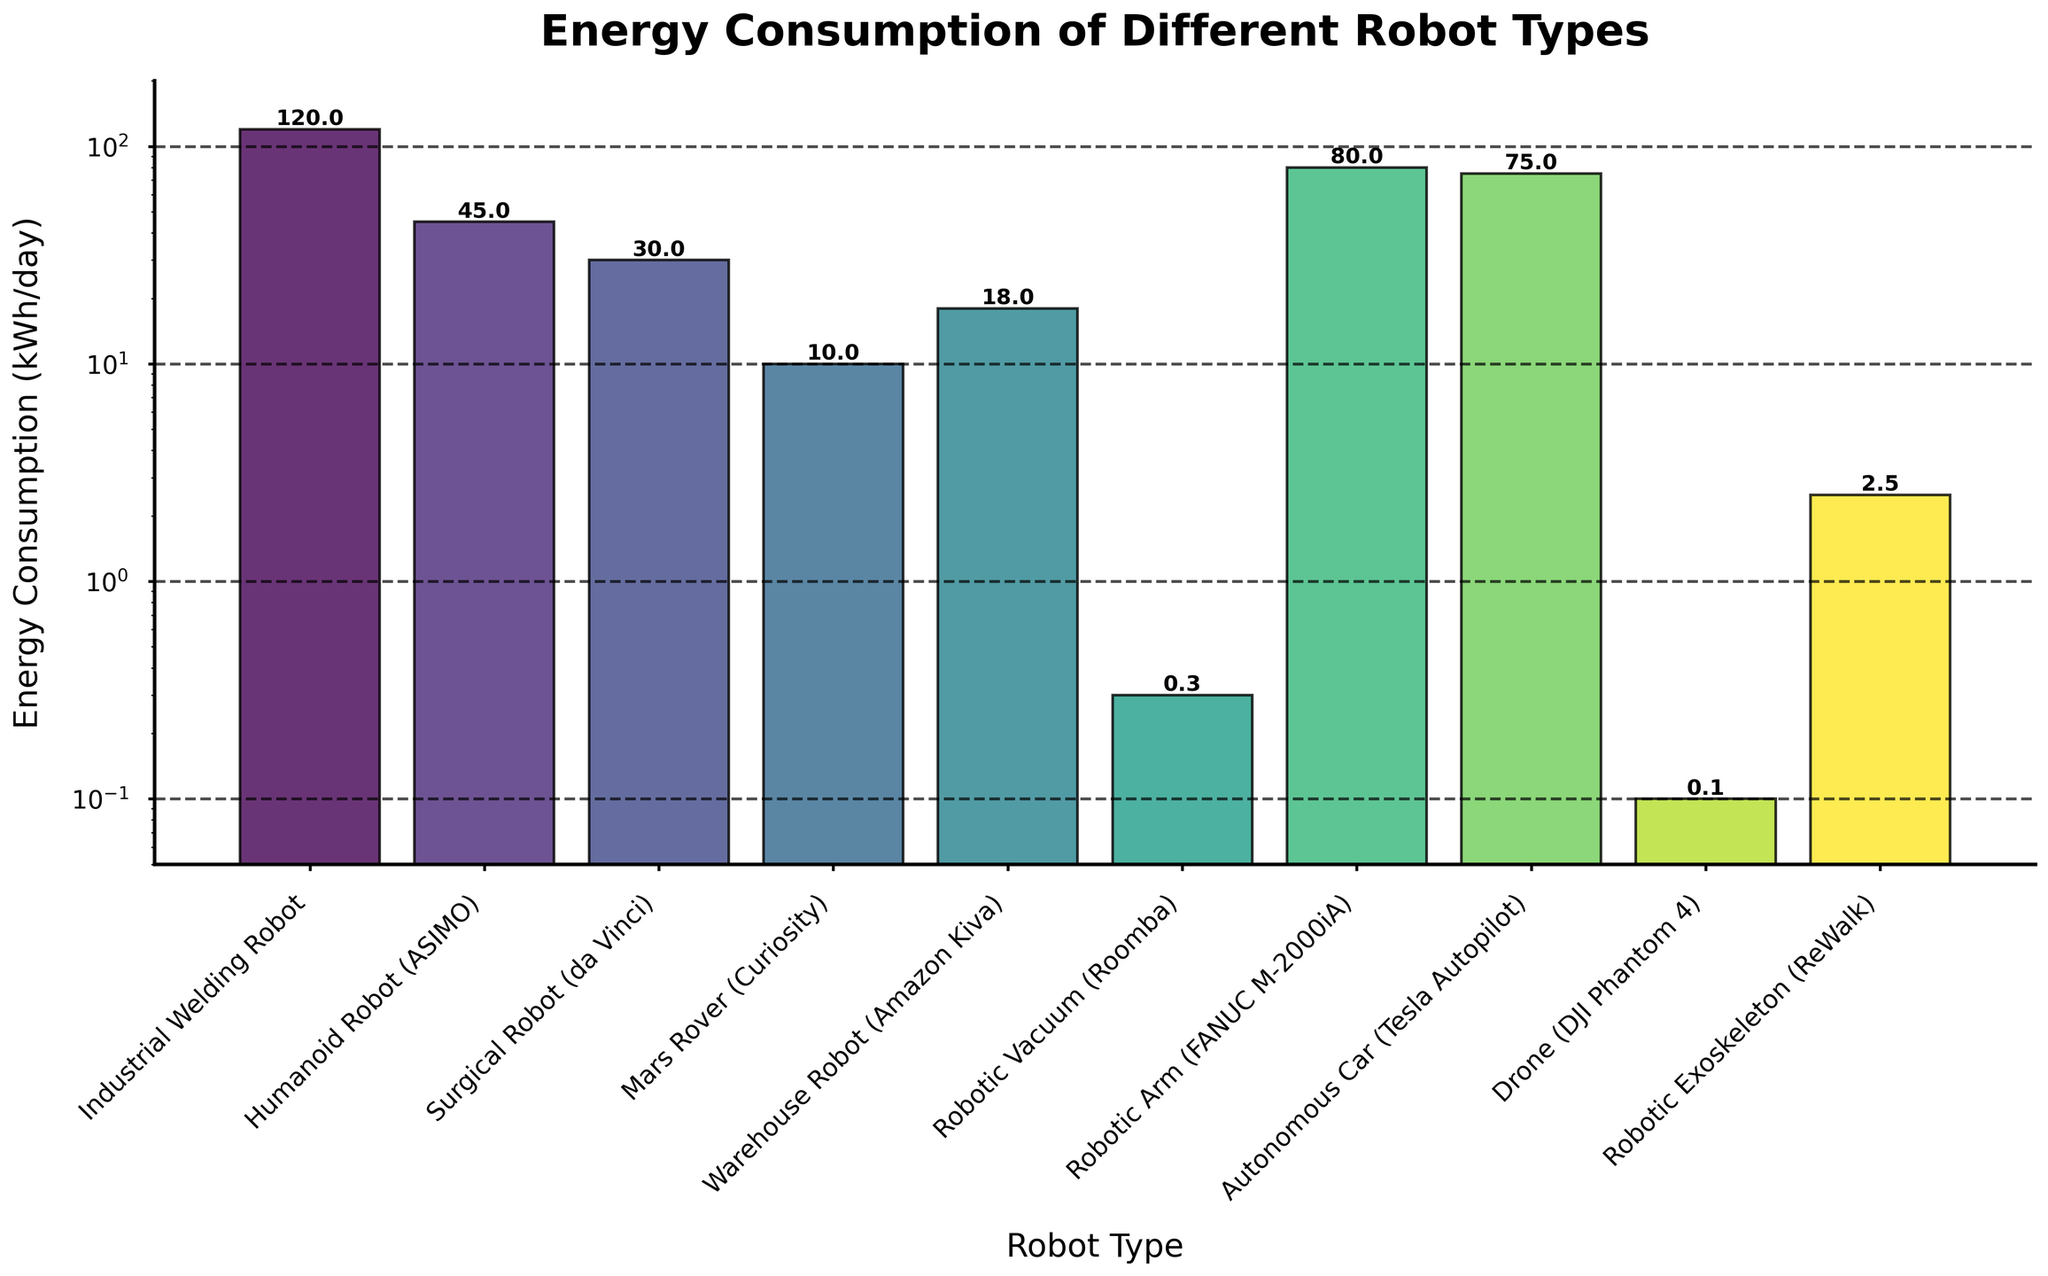What's the highest energy consumption of the robots shown on the chart? The bar with the highest height represents the Industrial Welding Robot with an energy consumption value of 120 kWh/day.
Answer: 120 kWh/day Which robot type consumes the least energy? The shortest bar on the chart represents the Drone (DJI Phantom 4), with an energy consumption of 0.1 kWh/day.
Answer: Drone (DJI Phantom 4) What's the combined energy consumption of the Industrial Welding Robot and the Robotic Arm? The energy consumption for the Industrial Welding Robot is 120 kWh/day, and for the Robotic Arm, it is 80 kWh/day. Adding these two values: 120 + 80 = 200 kWh/day.
Answer: 200 kWh/day Is the energy consumption of the Autonomous Car higher than that of the Humanoid Robot? The bar representing the Autonomous Car (Tesla Autopilot) has a height corresponding to 75 kWh/day, while the Humanoid Robot (ASIMO) has a height corresponding to 45 kWh/day. Since 75 is greater than 45, the energy consumption of the Autonomous Car is higher.
Answer: Yes What is the difference in energy consumption between the Surgical Robot and the Warehouse Robot? The energy consumption of the Surgical Robot (da Vinci) is 30 kWh/day, and that of the Warehouse Robot (Amazon Kiva) is 18 kWh/day. The difference is 30 - 18 = 12 kWh/day.
Answer: 12 kWh/day Is the energy consumption of the Mars Rover lower than that of the Robotic Exoskeleton? Comparing the heights of the bars, the Mars Rover (Curiosity) consumes 10 kWh/day while the Robotic Exoskeleton (ReWalk) consumes 2.5 kWh/day. Since 2.5 is less than 10, the Mars Rover's consumption is higher.
Answer: No Which three robots have the lowest energy consumption? By glancing at the shortest bars in ascending order: Drone (DJI Phantom 4) with 0.1 kWh/day, Robotic Vacuum (Roomba) with 0.3 kWh/day, and Robotic Exoskeleton (ReWalk) with 2.5 kWh/day.
Answer: Drone, Roomba, ReWalk What portion of the total energy consumption is taken up by the Autonomous Car? Total energy consumption of all robots is: 120 + 45 + 30 + 10 + 18 + 0.3 + 80 + 75 + 0.1 + 2.5 = 381.9 kWh/day. The Autonomous Car consumes 75 kWh/day. Proportion is 75 / 381.9 ≈ 0.196 or 19.6%.
Answer: 19.6% What is the average energy consumption of the listed robots? Sum all energy consumption values: 120 + 45 + 30 + 10 + 18 + 0.3 + 80 + 75 + 0.1 + 2.5 = 381.9 kWh/day. There are 10 robot types, so average is 381.9 / 10 = 38.19 kWh/day.
Answer: 38.19 kWh/day Which robot types have energy consumption above the average? The average is 38.19 kWh/day. Robots with higher consumption are: Industrial Welding Robot (120), Humanoid Robot (45), Robotic Arm (80), and Autonomous Car (75).
Answer: Industrial Welding Robot, Humanoid Robot, Robotic Arm, Autonomous Car 